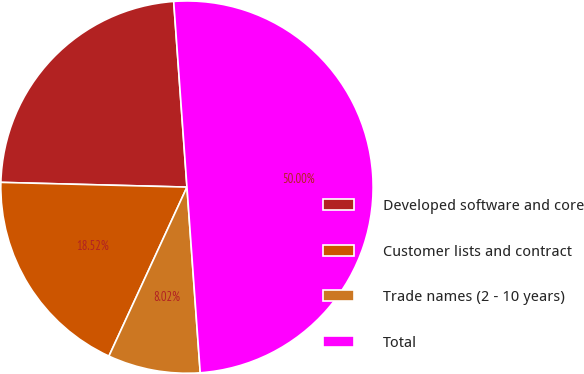Convert chart to OTSL. <chart><loc_0><loc_0><loc_500><loc_500><pie_chart><fcel>Developed software and core<fcel>Customer lists and contract<fcel>Trade names (2 - 10 years)<fcel>Total<nl><fcel>23.46%<fcel>18.52%<fcel>8.02%<fcel>50.0%<nl></chart> 